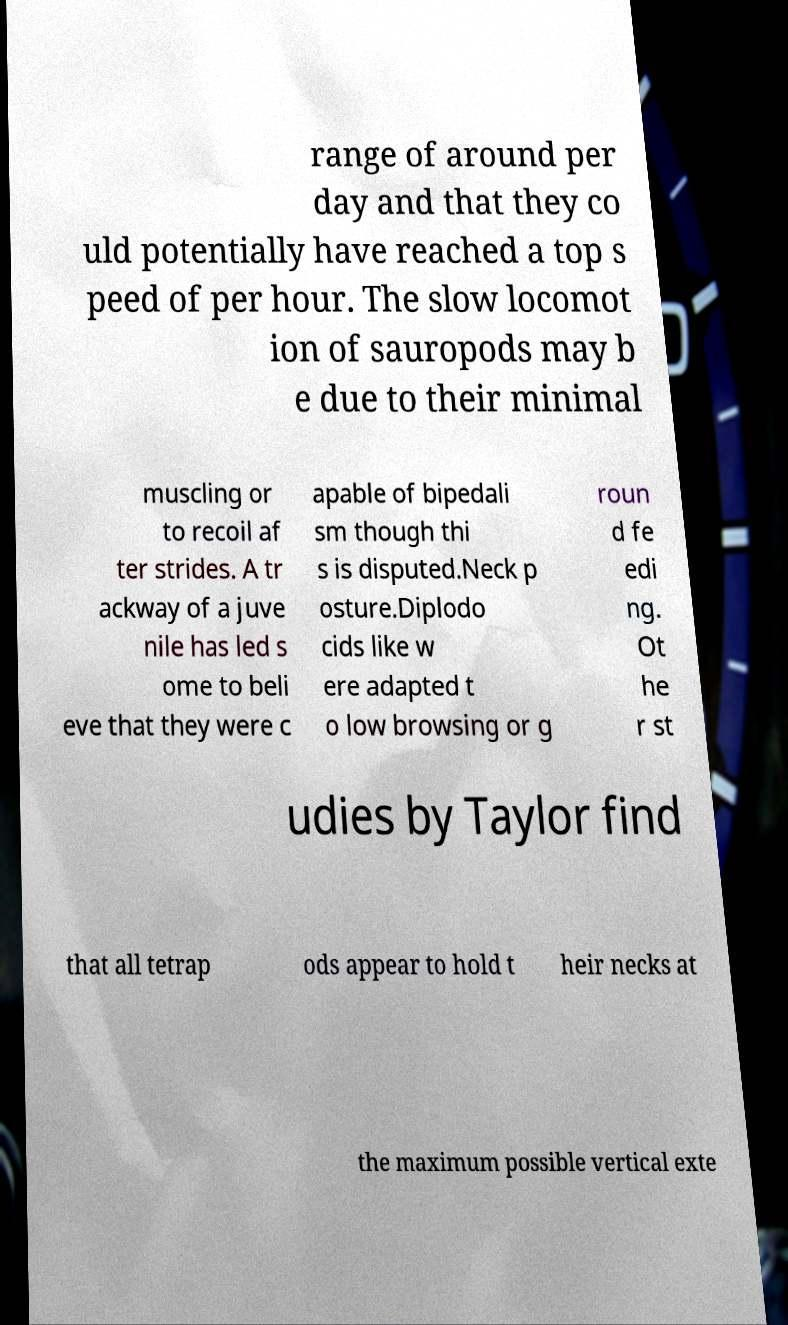Can you read and provide the text displayed in the image?This photo seems to have some interesting text. Can you extract and type it out for me? range of around per day and that they co uld potentially have reached a top s peed of per hour. The slow locomot ion of sauropods may b e due to their minimal muscling or to recoil af ter strides. A tr ackway of a juve nile has led s ome to beli eve that they were c apable of bipedali sm though thi s is disputed.Neck p osture.Diplodo cids like w ere adapted t o low browsing or g roun d fe edi ng. Ot he r st udies by Taylor find that all tetrap ods appear to hold t heir necks at the maximum possible vertical exte 